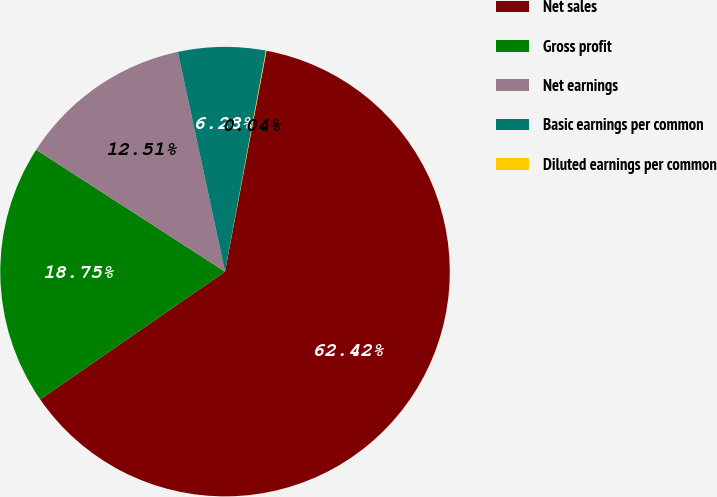Convert chart. <chart><loc_0><loc_0><loc_500><loc_500><pie_chart><fcel>Net sales<fcel>Gross profit<fcel>Net earnings<fcel>Basic earnings per common<fcel>Diluted earnings per common<nl><fcel>62.42%<fcel>18.75%<fcel>12.51%<fcel>6.28%<fcel>0.04%<nl></chart> 